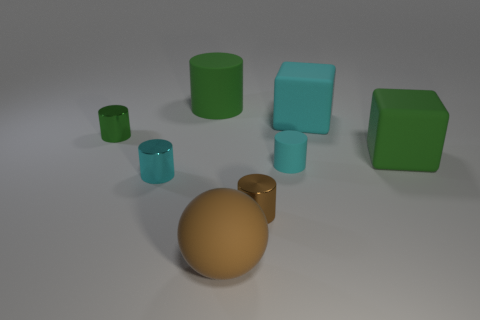There is a green object that is the same material as the large green cube; what is its shape?
Give a very brief answer. Cylinder. There is a tiny brown shiny thing; is its shape the same as the big green matte object behind the tiny green object?
Offer a very short reply. Yes. What material is the cyan cylinder to the left of the large brown object that is left of the brown cylinder?
Offer a terse response. Metal. Are there an equal number of small cyan cylinders that are behind the large cyan thing and large green matte blocks?
Offer a very short reply. No. Is the color of the small metal thing on the right side of the big brown matte sphere the same as the large ball left of the large green matte cube?
Your answer should be compact. Yes. What number of rubber objects are both behind the large brown matte ball and in front of the small green metallic cylinder?
Your answer should be compact. 2. What number of other objects are there of the same shape as the cyan shiny thing?
Give a very brief answer. 4. Are there more tiny cylinders that are left of the cyan metal object than gray shiny spheres?
Offer a terse response. Yes. There is a rubber thing that is behind the large cyan cube; what is its color?
Give a very brief answer. Green. There is a rubber thing that is the same color as the large cylinder; what is its size?
Your answer should be very brief. Large. 